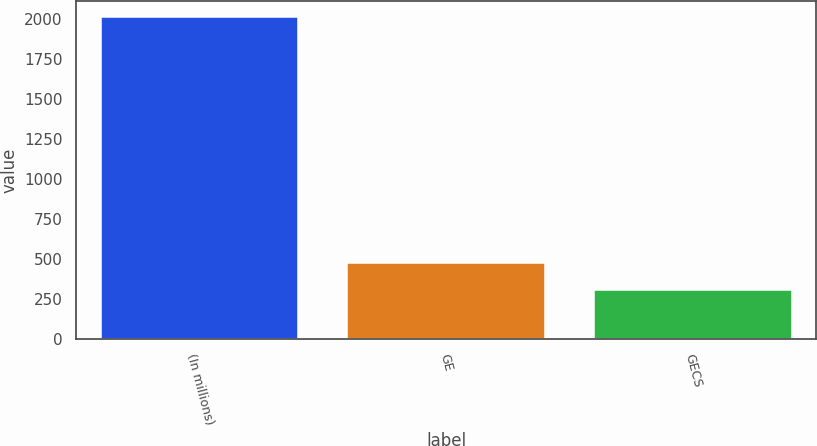<chart> <loc_0><loc_0><loc_500><loc_500><bar_chart><fcel>(In millions)<fcel>GE<fcel>GECS<nl><fcel>2013<fcel>476.7<fcel>306<nl></chart> 